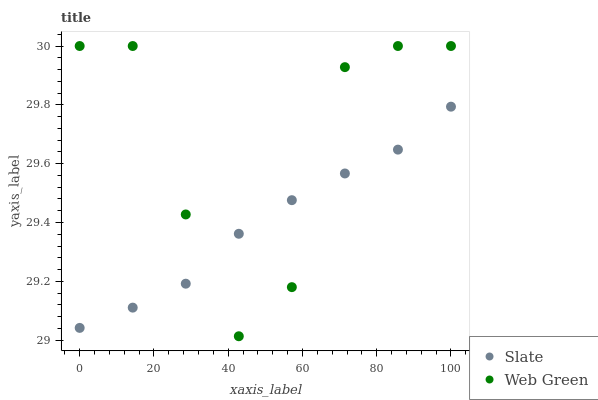Does Slate have the minimum area under the curve?
Answer yes or no. Yes. Does Web Green have the maximum area under the curve?
Answer yes or no. Yes. Does Web Green have the minimum area under the curve?
Answer yes or no. No. Is Slate the smoothest?
Answer yes or no. Yes. Is Web Green the roughest?
Answer yes or no. Yes. Is Web Green the smoothest?
Answer yes or no. No. Does Web Green have the lowest value?
Answer yes or no. Yes. Does Web Green have the highest value?
Answer yes or no. Yes. Does Slate intersect Web Green?
Answer yes or no. Yes. Is Slate less than Web Green?
Answer yes or no. No. Is Slate greater than Web Green?
Answer yes or no. No. 